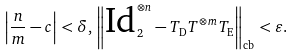<formula> <loc_0><loc_0><loc_500><loc_500>\left | \frac { n } { m } - c \right | < \delta , \, \left \| \text {Id} ^ { \otimes n } _ { 2 } - T _ { \text {D} } T ^ { \otimes m } T _ { \text {E} } \right \| _ { \text {cb} } < \varepsilon .</formula> 